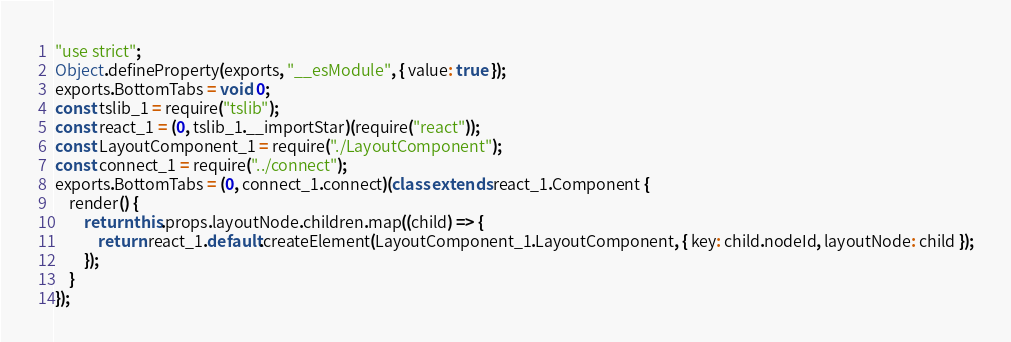<code> <loc_0><loc_0><loc_500><loc_500><_JavaScript_>"use strict";
Object.defineProperty(exports, "__esModule", { value: true });
exports.BottomTabs = void 0;
const tslib_1 = require("tslib");
const react_1 = (0, tslib_1.__importStar)(require("react"));
const LayoutComponent_1 = require("./LayoutComponent");
const connect_1 = require("../connect");
exports.BottomTabs = (0, connect_1.connect)(class extends react_1.Component {
    render() {
        return this.props.layoutNode.children.map((child) => {
            return react_1.default.createElement(LayoutComponent_1.LayoutComponent, { key: child.nodeId, layoutNode: child });
        });
    }
});
</code> 